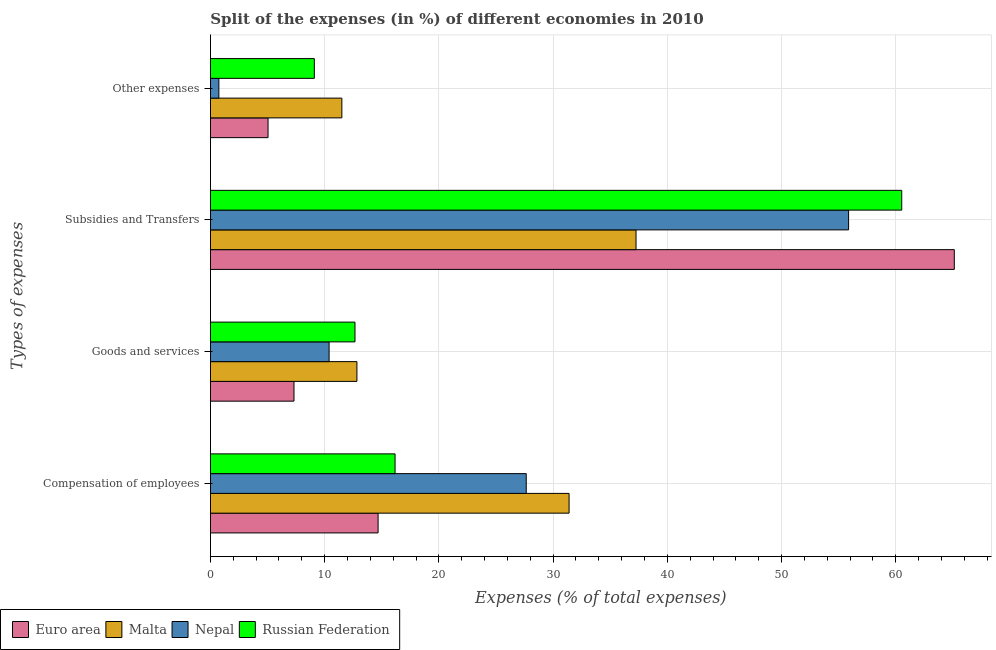How many bars are there on the 4th tick from the bottom?
Your answer should be compact. 4. What is the label of the 3rd group of bars from the top?
Offer a very short reply. Goods and services. What is the percentage of amount spent on compensation of employees in Nepal?
Provide a short and direct response. 27.65. Across all countries, what is the maximum percentage of amount spent on compensation of employees?
Ensure brevity in your answer.  31.4. Across all countries, what is the minimum percentage of amount spent on other expenses?
Make the answer very short. 0.74. In which country was the percentage of amount spent on compensation of employees maximum?
Provide a succinct answer. Malta. In which country was the percentage of amount spent on other expenses minimum?
Provide a succinct answer. Nepal. What is the total percentage of amount spent on goods and services in the graph?
Offer a terse response. 43.2. What is the difference between the percentage of amount spent on other expenses in Russian Federation and that in Malta?
Give a very brief answer. -2.41. What is the difference between the percentage of amount spent on compensation of employees in Malta and the percentage of amount spent on subsidies in Nepal?
Provide a succinct answer. -24.47. What is the average percentage of amount spent on compensation of employees per country?
Your answer should be very brief. 22.47. What is the difference between the percentage of amount spent on goods and services and percentage of amount spent on compensation of employees in Euro area?
Give a very brief answer. -7.36. What is the ratio of the percentage of amount spent on compensation of employees in Euro area to that in Nepal?
Your response must be concise. 0.53. Is the percentage of amount spent on goods and services in Euro area less than that in Malta?
Offer a very short reply. Yes. Is the difference between the percentage of amount spent on other expenses in Malta and Nepal greater than the difference between the percentage of amount spent on compensation of employees in Malta and Nepal?
Offer a terse response. Yes. What is the difference between the highest and the second highest percentage of amount spent on compensation of employees?
Ensure brevity in your answer.  3.75. What is the difference between the highest and the lowest percentage of amount spent on goods and services?
Provide a succinct answer. 5.51. In how many countries, is the percentage of amount spent on other expenses greater than the average percentage of amount spent on other expenses taken over all countries?
Offer a terse response. 2. Is the sum of the percentage of amount spent on compensation of employees in Russian Federation and Malta greater than the maximum percentage of amount spent on other expenses across all countries?
Provide a short and direct response. Yes. Is it the case that in every country, the sum of the percentage of amount spent on subsidies and percentage of amount spent on other expenses is greater than the sum of percentage of amount spent on goods and services and percentage of amount spent on compensation of employees?
Provide a short and direct response. No. What does the 2nd bar from the bottom in Compensation of employees represents?
Provide a succinct answer. Malta. How many bars are there?
Give a very brief answer. 16. Are all the bars in the graph horizontal?
Give a very brief answer. Yes. How many countries are there in the graph?
Offer a terse response. 4. What is the difference between two consecutive major ticks on the X-axis?
Make the answer very short. 10. Are the values on the major ticks of X-axis written in scientific E-notation?
Provide a succinct answer. No. Does the graph contain grids?
Offer a terse response. Yes. Where does the legend appear in the graph?
Your answer should be very brief. Bottom left. How many legend labels are there?
Ensure brevity in your answer.  4. How are the legend labels stacked?
Provide a succinct answer. Horizontal. What is the title of the graph?
Keep it short and to the point. Split of the expenses (in %) of different economies in 2010. What is the label or title of the X-axis?
Offer a very short reply. Expenses (% of total expenses). What is the label or title of the Y-axis?
Make the answer very short. Types of expenses. What is the Expenses (% of total expenses) of Euro area in Compensation of employees?
Offer a terse response. 14.68. What is the Expenses (% of total expenses) of Malta in Compensation of employees?
Ensure brevity in your answer.  31.4. What is the Expenses (% of total expenses) in Nepal in Compensation of employees?
Offer a terse response. 27.65. What is the Expenses (% of total expenses) in Russian Federation in Compensation of employees?
Provide a short and direct response. 16.17. What is the Expenses (% of total expenses) of Euro area in Goods and services?
Keep it short and to the point. 7.32. What is the Expenses (% of total expenses) of Malta in Goods and services?
Make the answer very short. 12.83. What is the Expenses (% of total expenses) of Nepal in Goods and services?
Offer a very short reply. 10.39. What is the Expenses (% of total expenses) of Russian Federation in Goods and services?
Give a very brief answer. 12.66. What is the Expenses (% of total expenses) in Euro area in Subsidies and Transfers?
Provide a succinct answer. 65.12. What is the Expenses (% of total expenses) in Malta in Subsidies and Transfers?
Keep it short and to the point. 37.26. What is the Expenses (% of total expenses) of Nepal in Subsidies and Transfers?
Your response must be concise. 55.87. What is the Expenses (% of total expenses) of Russian Federation in Subsidies and Transfers?
Ensure brevity in your answer.  60.52. What is the Expenses (% of total expenses) of Euro area in Other expenses?
Your response must be concise. 5.05. What is the Expenses (% of total expenses) of Malta in Other expenses?
Make the answer very short. 11.51. What is the Expenses (% of total expenses) in Nepal in Other expenses?
Ensure brevity in your answer.  0.74. What is the Expenses (% of total expenses) in Russian Federation in Other expenses?
Your answer should be compact. 9.1. Across all Types of expenses, what is the maximum Expenses (% of total expenses) in Euro area?
Make the answer very short. 65.12. Across all Types of expenses, what is the maximum Expenses (% of total expenses) in Malta?
Provide a succinct answer. 37.26. Across all Types of expenses, what is the maximum Expenses (% of total expenses) in Nepal?
Give a very brief answer. 55.87. Across all Types of expenses, what is the maximum Expenses (% of total expenses) of Russian Federation?
Your answer should be very brief. 60.52. Across all Types of expenses, what is the minimum Expenses (% of total expenses) in Euro area?
Your answer should be compact. 5.05. Across all Types of expenses, what is the minimum Expenses (% of total expenses) of Malta?
Provide a short and direct response. 11.51. Across all Types of expenses, what is the minimum Expenses (% of total expenses) of Nepal?
Offer a very short reply. 0.74. Across all Types of expenses, what is the minimum Expenses (% of total expenses) in Russian Federation?
Offer a very short reply. 9.1. What is the total Expenses (% of total expenses) of Euro area in the graph?
Your response must be concise. 92.17. What is the total Expenses (% of total expenses) in Malta in the graph?
Offer a very short reply. 92.99. What is the total Expenses (% of total expenses) in Nepal in the graph?
Offer a very short reply. 94.65. What is the total Expenses (% of total expenses) of Russian Federation in the graph?
Ensure brevity in your answer.  98.44. What is the difference between the Expenses (% of total expenses) of Euro area in Compensation of employees and that in Goods and services?
Offer a terse response. 7.36. What is the difference between the Expenses (% of total expenses) in Malta in Compensation of employees and that in Goods and services?
Offer a very short reply. 18.57. What is the difference between the Expenses (% of total expenses) in Nepal in Compensation of employees and that in Goods and services?
Your answer should be very brief. 17.26. What is the difference between the Expenses (% of total expenses) in Russian Federation in Compensation of employees and that in Goods and services?
Your answer should be very brief. 3.51. What is the difference between the Expenses (% of total expenses) in Euro area in Compensation of employees and that in Subsidies and Transfers?
Your answer should be compact. -50.44. What is the difference between the Expenses (% of total expenses) of Malta in Compensation of employees and that in Subsidies and Transfers?
Provide a short and direct response. -5.86. What is the difference between the Expenses (% of total expenses) in Nepal in Compensation of employees and that in Subsidies and Transfers?
Offer a terse response. -28.22. What is the difference between the Expenses (% of total expenses) in Russian Federation in Compensation of employees and that in Subsidies and Transfers?
Give a very brief answer. -44.35. What is the difference between the Expenses (% of total expenses) in Euro area in Compensation of employees and that in Other expenses?
Give a very brief answer. 9.63. What is the difference between the Expenses (% of total expenses) in Malta in Compensation of employees and that in Other expenses?
Ensure brevity in your answer.  19.89. What is the difference between the Expenses (% of total expenses) in Nepal in Compensation of employees and that in Other expenses?
Give a very brief answer. 26.91. What is the difference between the Expenses (% of total expenses) of Russian Federation in Compensation of employees and that in Other expenses?
Give a very brief answer. 7.07. What is the difference between the Expenses (% of total expenses) of Euro area in Goods and services and that in Subsidies and Transfers?
Keep it short and to the point. -57.8. What is the difference between the Expenses (% of total expenses) of Malta in Goods and services and that in Subsidies and Transfers?
Offer a very short reply. -24.43. What is the difference between the Expenses (% of total expenses) in Nepal in Goods and services and that in Subsidies and Transfers?
Your answer should be very brief. -45.47. What is the difference between the Expenses (% of total expenses) in Russian Federation in Goods and services and that in Subsidies and Transfers?
Keep it short and to the point. -47.86. What is the difference between the Expenses (% of total expenses) in Euro area in Goods and services and that in Other expenses?
Provide a succinct answer. 2.27. What is the difference between the Expenses (% of total expenses) in Malta in Goods and services and that in Other expenses?
Provide a succinct answer. 1.32. What is the difference between the Expenses (% of total expenses) of Nepal in Goods and services and that in Other expenses?
Offer a very short reply. 9.65. What is the difference between the Expenses (% of total expenses) of Russian Federation in Goods and services and that in Other expenses?
Offer a terse response. 3.56. What is the difference between the Expenses (% of total expenses) of Euro area in Subsidies and Transfers and that in Other expenses?
Offer a terse response. 60.07. What is the difference between the Expenses (% of total expenses) of Malta in Subsidies and Transfers and that in Other expenses?
Ensure brevity in your answer.  25.75. What is the difference between the Expenses (% of total expenses) of Nepal in Subsidies and Transfers and that in Other expenses?
Ensure brevity in your answer.  55.12. What is the difference between the Expenses (% of total expenses) of Russian Federation in Subsidies and Transfers and that in Other expenses?
Keep it short and to the point. 51.42. What is the difference between the Expenses (% of total expenses) of Euro area in Compensation of employees and the Expenses (% of total expenses) of Malta in Goods and services?
Provide a short and direct response. 1.85. What is the difference between the Expenses (% of total expenses) in Euro area in Compensation of employees and the Expenses (% of total expenses) in Nepal in Goods and services?
Provide a succinct answer. 4.29. What is the difference between the Expenses (% of total expenses) in Euro area in Compensation of employees and the Expenses (% of total expenses) in Russian Federation in Goods and services?
Ensure brevity in your answer.  2.02. What is the difference between the Expenses (% of total expenses) of Malta in Compensation of employees and the Expenses (% of total expenses) of Nepal in Goods and services?
Keep it short and to the point. 21.01. What is the difference between the Expenses (% of total expenses) in Malta in Compensation of employees and the Expenses (% of total expenses) in Russian Federation in Goods and services?
Ensure brevity in your answer.  18.74. What is the difference between the Expenses (% of total expenses) in Nepal in Compensation of employees and the Expenses (% of total expenses) in Russian Federation in Goods and services?
Your answer should be very brief. 14.99. What is the difference between the Expenses (% of total expenses) of Euro area in Compensation of employees and the Expenses (% of total expenses) of Malta in Subsidies and Transfers?
Offer a terse response. -22.58. What is the difference between the Expenses (% of total expenses) in Euro area in Compensation of employees and the Expenses (% of total expenses) in Nepal in Subsidies and Transfers?
Offer a very short reply. -41.19. What is the difference between the Expenses (% of total expenses) in Euro area in Compensation of employees and the Expenses (% of total expenses) in Russian Federation in Subsidies and Transfers?
Your answer should be compact. -45.84. What is the difference between the Expenses (% of total expenses) of Malta in Compensation of employees and the Expenses (% of total expenses) of Nepal in Subsidies and Transfers?
Ensure brevity in your answer.  -24.47. What is the difference between the Expenses (% of total expenses) in Malta in Compensation of employees and the Expenses (% of total expenses) in Russian Federation in Subsidies and Transfers?
Make the answer very short. -29.12. What is the difference between the Expenses (% of total expenses) in Nepal in Compensation of employees and the Expenses (% of total expenses) in Russian Federation in Subsidies and Transfers?
Offer a terse response. -32.87. What is the difference between the Expenses (% of total expenses) of Euro area in Compensation of employees and the Expenses (% of total expenses) of Malta in Other expenses?
Ensure brevity in your answer.  3.17. What is the difference between the Expenses (% of total expenses) in Euro area in Compensation of employees and the Expenses (% of total expenses) in Nepal in Other expenses?
Keep it short and to the point. 13.94. What is the difference between the Expenses (% of total expenses) of Euro area in Compensation of employees and the Expenses (% of total expenses) of Russian Federation in Other expenses?
Keep it short and to the point. 5.58. What is the difference between the Expenses (% of total expenses) in Malta in Compensation of employees and the Expenses (% of total expenses) in Nepal in Other expenses?
Your answer should be very brief. 30.66. What is the difference between the Expenses (% of total expenses) of Malta in Compensation of employees and the Expenses (% of total expenses) of Russian Federation in Other expenses?
Offer a terse response. 22.3. What is the difference between the Expenses (% of total expenses) in Nepal in Compensation of employees and the Expenses (% of total expenses) in Russian Federation in Other expenses?
Your answer should be compact. 18.55. What is the difference between the Expenses (% of total expenses) of Euro area in Goods and services and the Expenses (% of total expenses) of Malta in Subsidies and Transfers?
Ensure brevity in your answer.  -29.94. What is the difference between the Expenses (% of total expenses) of Euro area in Goods and services and the Expenses (% of total expenses) of Nepal in Subsidies and Transfers?
Offer a very short reply. -48.55. What is the difference between the Expenses (% of total expenses) in Euro area in Goods and services and the Expenses (% of total expenses) in Russian Federation in Subsidies and Transfers?
Ensure brevity in your answer.  -53.2. What is the difference between the Expenses (% of total expenses) of Malta in Goods and services and the Expenses (% of total expenses) of Nepal in Subsidies and Transfers?
Provide a succinct answer. -43.04. What is the difference between the Expenses (% of total expenses) in Malta in Goods and services and the Expenses (% of total expenses) in Russian Federation in Subsidies and Transfers?
Give a very brief answer. -47.69. What is the difference between the Expenses (% of total expenses) of Nepal in Goods and services and the Expenses (% of total expenses) of Russian Federation in Subsidies and Transfers?
Offer a terse response. -50.13. What is the difference between the Expenses (% of total expenses) of Euro area in Goods and services and the Expenses (% of total expenses) of Malta in Other expenses?
Your answer should be very brief. -4.19. What is the difference between the Expenses (% of total expenses) of Euro area in Goods and services and the Expenses (% of total expenses) of Nepal in Other expenses?
Ensure brevity in your answer.  6.58. What is the difference between the Expenses (% of total expenses) of Euro area in Goods and services and the Expenses (% of total expenses) of Russian Federation in Other expenses?
Keep it short and to the point. -1.78. What is the difference between the Expenses (% of total expenses) in Malta in Goods and services and the Expenses (% of total expenses) in Nepal in Other expenses?
Provide a succinct answer. 12.09. What is the difference between the Expenses (% of total expenses) in Malta in Goods and services and the Expenses (% of total expenses) in Russian Federation in Other expenses?
Keep it short and to the point. 3.73. What is the difference between the Expenses (% of total expenses) in Nepal in Goods and services and the Expenses (% of total expenses) in Russian Federation in Other expenses?
Your answer should be compact. 1.29. What is the difference between the Expenses (% of total expenses) of Euro area in Subsidies and Transfers and the Expenses (% of total expenses) of Malta in Other expenses?
Your answer should be compact. 53.61. What is the difference between the Expenses (% of total expenses) in Euro area in Subsidies and Transfers and the Expenses (% of total expenses) in Nepal in Other expenses?
Your answer should be compact. 64.38. What is the difference between the Expenses (% of total expenses) of Euro area in Subsidies and Transfers and the Expenses (% of total expenses) of Russian Federation in Other expenses?
Your response must be concise. 56.02. What is the difference between the Expenses (% of total expenses) in Malta in Subsidies and Transfers and the Expenses (% of total expenses) in Nepal in Other expenses?
Offer a terse response. 36.52. What is the difference between the Expenses (% of total expenses) in Malta in Subsidies and Transfers and the Expenses (% of total expenses) in Russian Federation in Other expenses?
Give a very brief answer. 28.16. What is the difference between the Expenses (% of total expenses) of Nepal in Subsidies and Transfers and the Expenses (% of total expenses) of Russian Federation in Other expenses?
Provide a succinct answer. 46.77. What is the average Expenses (% of total expenses) of Euro area per Types of expenses?
Your answer should be very brief. 23.04. What is the average Expenses (% of total expenses) in Malta per Types of expenses?
Provide a succinct answer. 23.25. What is the average Expenses (% of total expenses) of Nepal per Types of expenses?
Your answer should be very brief. 23.66. What is the average Expenses (% of total expenses) of Russian Federation per Types of expenses?
Your answer should be very brief. 24.61. What is the difference between the Expenses (% of total expenses) of Euro area and Expenses (% of total expenses) of Malta in Compensation of employees?
Your answer should be very brief. -16.72. What is the difference between the Expenses (% of total expenses) of Euro area and Expenses (% of total expenses) of Nepal in Compensation of employees?
Offer a terse response. -12.97. What is the difference between the Expenses (% of total expenses) in Euro area and Expenses (% of total expenses) in Russian Federation in Compensation of employees?
Offer a very short reply. -1.48. What is the difference between the Expenses (% of total expenses) in Malta and Expenses (% of total expenses) in Nepal in Compensation of employees?
Make the answer very short. 3.75. What is the difference between the Expenses (% of total expenses) in Malta and Expenses (% of total expenses) in Russian Federation in Compensation of employees?
Provide a succinct answer. 15.23. What is the difference between the Expenses (% of total expenses) of Nepal and Expenses (% of total expenses) of Russian Federation in Compensation of employees?
Offer a terse response. 11.48. What is the difference between the Expenses (% of total expenses) in Euro area and Expenses (% of total expenses) in Malta in Goods and services?
Offer a terse response. -5.51. What is the difference between the Expenses (% of total expenses) of Euro area and Expenses (% of total expenses) of Nepal in Goods and services?
Ensure brevity in your answer.  -3.07. What is the difference between the Expenses (% of total expenses) in Euro area and Expenses (% of total expenses) in Russian Federation in Goods and services?
Provide a short and direct response. -5.34. What is the difference between the Expenses (% of total expenses) of Malta and Expenses (% of total expenses) of Nepal in Goods and services?
Provide a short and direct response. 2.44. What is the difference between the Expenses (% of total expenses) of Malta and Expenses (% of total expenses) of Russian Federation in Goods and services?
Your answer should be compact. 0.17. What is the difference between the Expenses (% of total expenses) of Nepal and Expenses (% of total expenses) of Russian Federation in Goods and services?
Make the answer very short. -2.27. What is the difference between the Expenses (% of total expenses) in Euro area and Expenses (% of total expenses) in Malta in Subsidies and Transfers?
Provide a succinct answer. 27.86. What is the difference between the Expenses (% of total expenses) of Euro area and Expenses (% of total expenses) of Nepal in Subsidies and Transfers?
Offer a terse response. 9.25. What is the difference between the Expenses (% of total expenses) in Euro area and Expenses (% of total expenses) in Russian Federation in Subsidies and Transfers?
Your answer should be very brief. 4.6. What is the difference between the Expenses (% of total expenses) of Malta and Expenses (% of total expenses) of Nepal in Subsidies and Transfers?
Your response must be concise. -18.61. What is the difference between the Expenses (% of total expenses) of Malta and Expenses (% of total expenses) of Russian Federation in Subsidies and Transfers?
Ensure brevity in your answer.  -23.26. What is the difference between the Expenses (% of total expenses) in Nepal and Expenses (% of total expenses) in Russian Federation in Subsidies and Transfers?
Provide a succinct answer. -4.65. What is the difference between the Expenses (% of total expenses) in Euro area and Expenses (% of total expenses) in Malta in Other expenses?
Give a very brief answer. -6.46. What is the difference between the Expenses (% of total expenses) in Euro area and Expenses (% of total expenses) in Nepal in Other expenses?
Your answer should be very brief. 4.3. What is the difference between the Expenses (% of total expenses) of Euro area and Expenses (% of total expenses) of Russian Federation in Other expenses?
Your answer should be very brief. -4.05. What is the difference between the Expenses (% of total expenses) of Malta and Expenses (% of total expenses) of Nepal in Other expenses?
Your answer should be compact. 10.77. What is the difference between the Expenses (% of total expenses) of Malta and Expenses (% of total expenses) of Russian Federation in Other expenses?
Your answer should be very brief. 2.41. What is the difference between the Expenses (% of total expenses) of Nepal and Expenses (% of total expenses) of Russian Federation in Other expenses?
Your response must be concise. -8.36. What is the ratio of the Expenses (% of total expenses) in Euro area in Compensation of employees to that in Goods and services?
Ensure brevity in your answer.  2.01. What is the ratio of the Expenses (% of total expenses) of Malta in Compensation of employees to that in Goods and services?
Your answer should be compact. 2.45. What is the ratio of the Expenses (% of total expenses) in Nepal in Compensation of employees to that in Goods and services?
Provide a short and direct response. 2.66. What is the ratio of the Expenses (% of total expenses) in Russian Federation in Compensation of employees to that in Goods and services?
Give a very brief answer. 1.28. What is the ratio of the Expenses (% of total expenses) in Euro area in Compensation of employees to that in Subsidies and Transfers?
Make the answer very short. 0.23. What is the ratio of the Expenses (% of total expenses) of Malta in Compensation of employees to that in Subsidies and Transfers?
Your answer should be very brief. 0.84. What is the ratio of the Expenses (% of total expenses) in Nepal in Compensation of employees to that in Subsidies and Transfers?
Your response must be concise. 0.49. What is the ratio of the Expenses (% of total expenses) in Russian Federation in Compensation of employees to that in Subsidies and Transfers?
Ensure brevity in your answer.  0.27. What is the ratio of the Expenses (% of total expenses) of Euro area in Compensation of employees to that in Other expenses?
Keep it short and to the point. 2.91. What is the ratio of the Expenses (% of total expenses) of Malta in Compensation of employees to that in Other expenses?
Your answer should be compact. 2.73. What is the ratio of the Expenses (% of total expenses) of Nepal in Compensation of employees to that in Other expenses?
Offer a very short reply. 37.25. What is the ratio of the Expenses (% of total expenses) of Russian Federation in Compensation of employees to that in Other expenses?
Offer a very short reply. 1.78. What is the ratio of the Expenses (% of total expenses) of Euro area in Goods and services to that in Subsidies and Transfers?
Offer a terse response. 0.11. What is the ratio of the Expenses (% of total expenses) in Malta in Goods and services to that in Subsidies and Transfers?
Make the answer very short. 0.34. What is the ratio of the Expenses (% of total expenses) of Nepal in Goods and services to that in Subsidies and Transfers?
Offer a very short reply. 0.19. What is the ratio of the Expenses (% of total expenses) of Russian Federation in Goods and services to that in Subsidies and Transfers?
Your response must be concise. 0.21. What is the ratio of the Expenses (% of total expenses) in Euro area in Goods and services to that in Other expenses?
Ensure brevity in your answer.  1.45. What is the ratio of the Expenses (% of total expenses) in Malta in Goods and services to that in Other expenses?
Provide a short and direct response. 1.11. What is the ratio of the Expenses (% of total expenses) of Nepal in Goods and services to that in Other expenses?
Ensure brevity in your answer.  14. What is the ratio of the Expenses (% of total expenses) in Russian Federation in Goods and services to that in Other expenses?
Your response must be concise. 1.39. What is the ratio of the Expenses (% of total expenses) in Euro area in Subsidies and Transfers to that in Other expenses?
Make the answer very short. 12.9. What is the ratio of the Expenses (% of total expenses) in Malta in Subsidies and Transfers to that in Other expenses?
Offer a very short reply. 3.24. What is the ratio of the Expenses (% of total expenses) in Nepal in Subsidies and Transfers to that in Other expenses?
Make the answer very short. 75.27. What is the ratio of the Expenses (% of total expenses) of Russian Federation in Subsidies and Transfers to that in Other expenses?
Your answer should be very brief. 6.65. What is the difference between the highest and the second highest Expenses (% of total expenses) of Euro area?
Provide a short and direct response. 50.44. What is the difference between the highest and the second highest Expenses (% of total expenses) in Malta?
Make the answer very short. 5.86. What is the difference between the highest and the second highest Expenses (% of total expenses) in Nepal?
Offer a terse response. 28.22. What is the difference between the highest and the second highest Expenses (% of total expenses) of Russian Federation?
Offer a terse response. 44.35. What is the difference between the highest and the lowest Expenses (% of total expenses) of Euro area?
Provide a short and direct response. 60.07. What is the difference between the highest and the lowest Expenses (% of total expenses) of Malta?
Keep it short and to the point. 25.75. What is the difference between the highest and the lowest Expenses (% of total expenses) in Nepal?
Offer a very short reply. 55.12. What is the difference between the highest and the lowest Expenses (% of total expenses) of Russian Federation?
Provide a succinct answer. 51.42. 